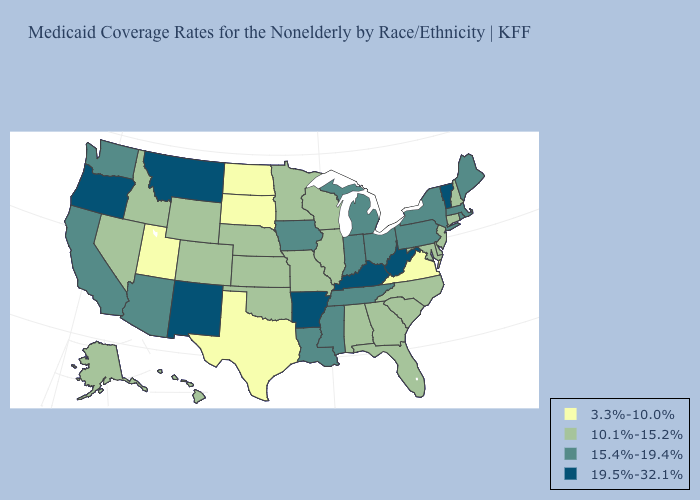What is the value of Maryland?
Concise answer only. 10.1%-15.2%. Among the states that border Rhode Island , which have the lowest value?
Keep it brief. Connecticut. What is the lowest value in the Northeast?
Answer briefly. 10.1%-15.2%. Name the states that have a value in the range 19.5%-32.1%?
Give a very brief answer. Arkansas, Kentucky, Montana, New Mexico, Oregon, Vermont, West Virginia. Name the states that have a value in the range 3.3%-10.0%?
Answer briefly. North Dakota, South Dakota, Texas, Utah, Virginia. Does Washington have a lower value than Colorado?
Short answer required. No. Is the legend a continuous bar?
Keep it brief. No. Among the states that border New Hampshire , which have the lowest value?
Concise answer only. Maine, Massachusetts. What is the value of North Carolina?
Answer briefly. 10.1%-15.2%. Among the states that border Kentucky , does Ohio have the lowest value?
Short answer required. No. Name the states that have a value in the range 19.5%-32.1%?
Quick response, please. Arkansas, Kentucky, Montana, New Mexico, Oregon, Vermont, West Virginia. What is the highest value in the USA?
Give a very brief answer. 19.5%-32.1%. Name the states that have a value in the range 15.4%-19.4%?
Quick response, please. Arizona, California, Indiana, Iowa, Louisiana, Maine, Massachusetts, Michigan, Mississippi, New York, Ohio, Pennsylvania, Rhode Island, Tennessee, Washington. Name the states that have a value in the range 3.3%-10.0%?
Give a very brief answer. North Dakota, South Dakota, Texas, Utah, Virginia. Name the states that have a value in the range 19.5%-32.1%?
Concise answer only. Arkansas, Kentucky, Montana, New Mexico, Oregon, Vermont, West Virginia. 